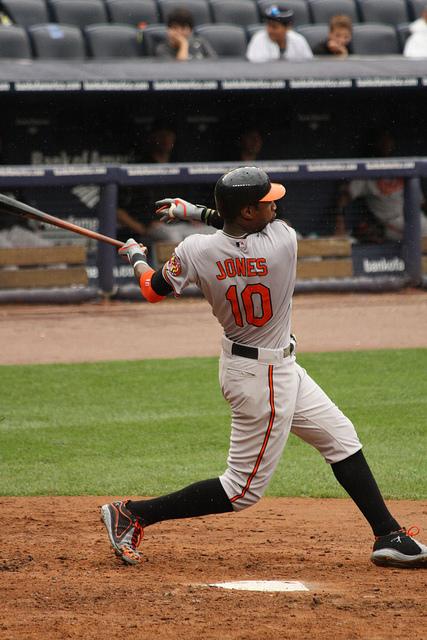What is the players name?
Keep it brief. Jones. Are the player's pants dirty?
Give a very brief answer. No. What MLB team colors is he wearing?
Give a very brief answer. Orioles. What number is he?
Keep it brief. 10. What is the number on the shirt?
Short answer required. 10. What is the player's name?
Concise answer only. Jones. What is the player's number?
Give a very brief answer. 10. Is there anyone in the dugout?
Short answer required. Yes. Is the stadium full of people?
Give a very brief answer. No. What is the number on the players uniform?
Answer briefly. 10. What is the name on his shirt?
Keep it brief. Jones. What position does he play?
Concise answer only. Batter. 